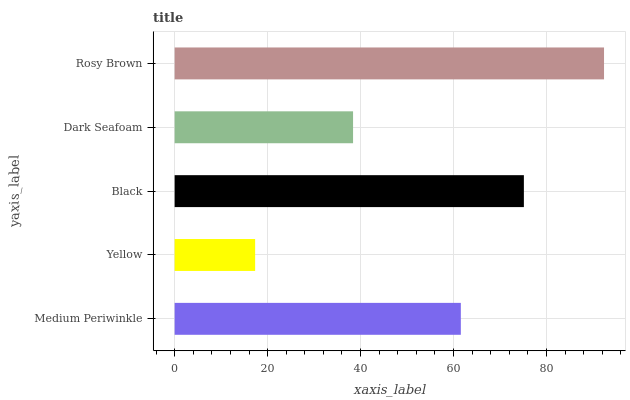Is Yellow the minimum?
Answer yes or no. Yes. Is Rosy Brown the maximum?
Answer yes or no. Yes. Is Black the minimum?
Answer yes or no. No. Is Black the maximum?
Answer yes or no. No. Is Black greater than Yellow?
Answer yes or no. Yes. Is Yellow less than Black?
Answer yes or no. Yes. Is Yellow greater than Black?
Answer yes or no. No. Is Black less than Yellow?
Answer yes or no. No. Is Medium Periwinkle the high median?
Answer yes or no. Yes. Is Medium Periwinkle the low median?
Answer yes or no. Yes. Is Dark Seafoam the high median?
Answer yes or no. No. Is Dark Seafoam the low median?
Answer yes or no. No. 